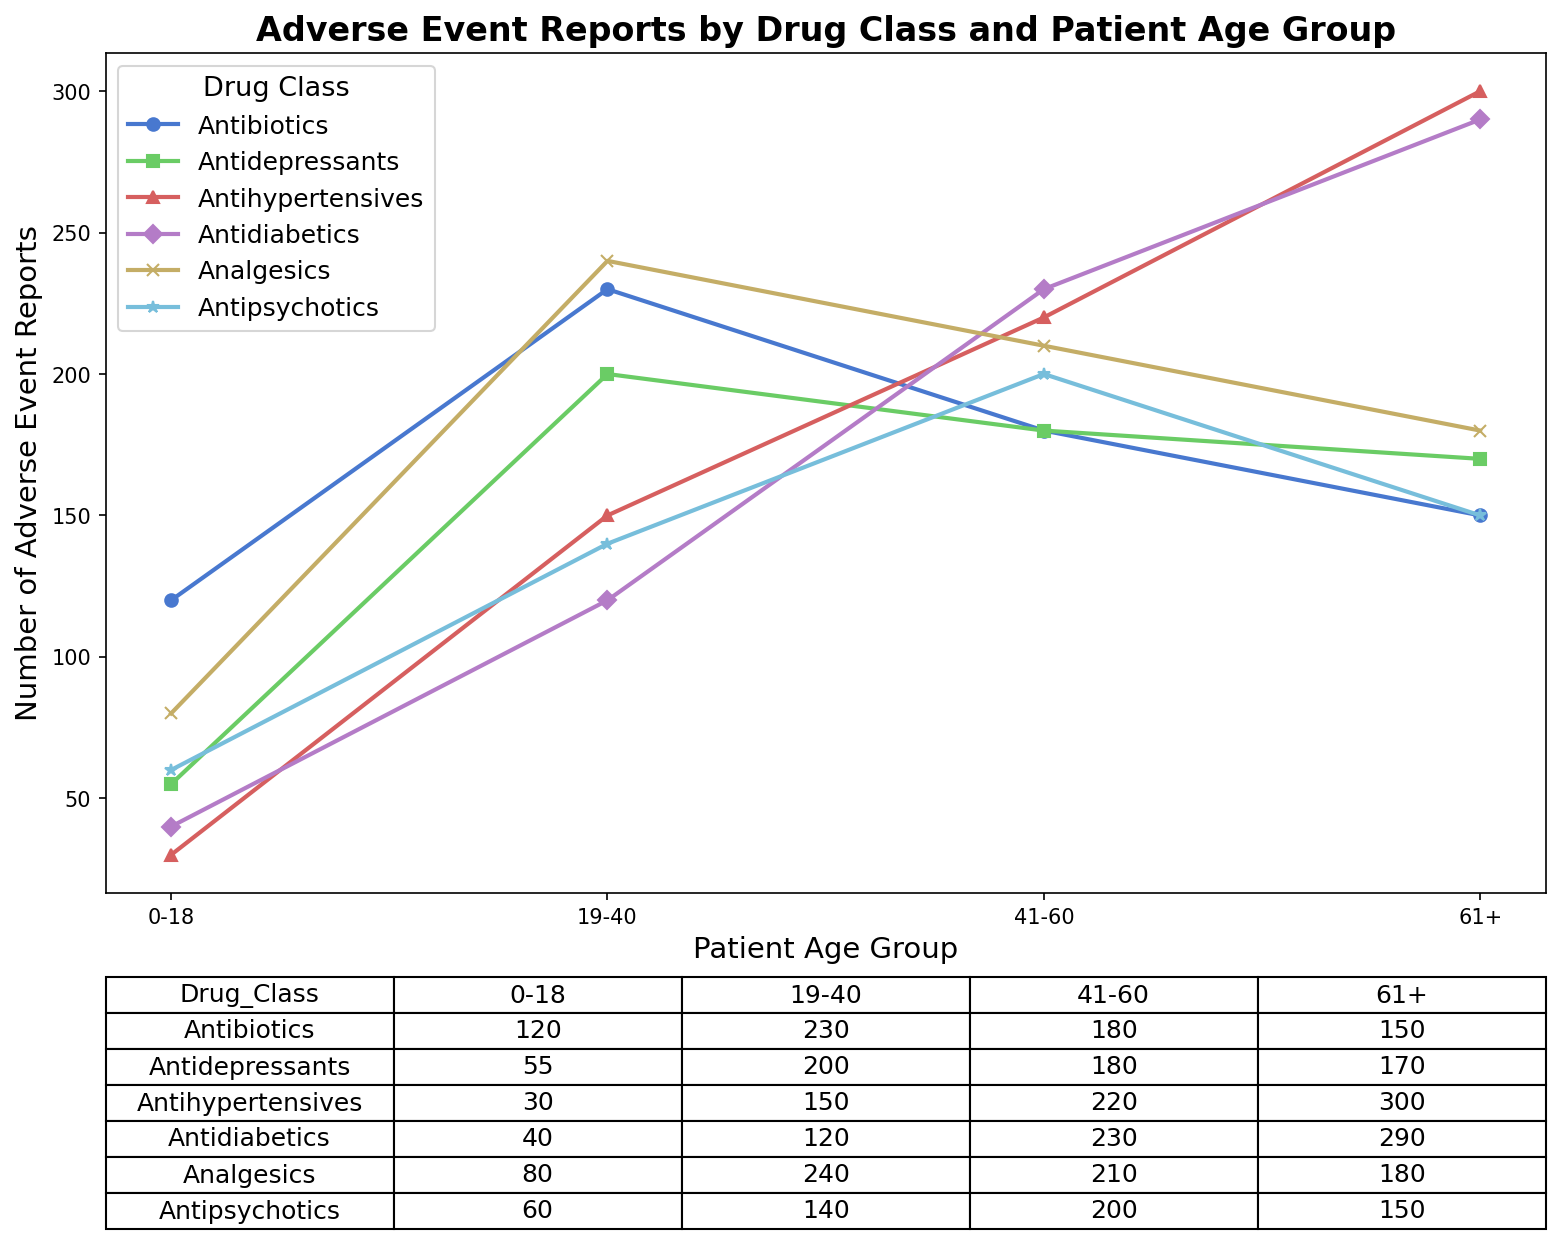Which drug class has the highest number of adverse event reports for the 61+ age group? Look at the 61+ age group column in the table and identify the drug class with the highest number, which is 300 for Antihypertensives.
Answer: Antihypertensives Which age group reports the most adverse events for Antibiotics? For Antibiotics, compare the numbers across the age groups: 0-18 (120), 19-40 (230), 41-60 (180), 61+ (150). The highest number is 230 for the 19-40 age group.
Answer: 19-40 How many more adverse event reports are there for Antihypertensives in the 61+ age group compared to the 0-18 age group? Subtract the number of reports for the 0-18 age group (30) from the number of reports for the 61+ age group (300). 300 - 30 = 270.
Answer: 270 Which drug class has the least number of adverse event reports for the 19-40 age group? Compare the numbers in the 19-40 age group column: Antibiotics (230), Antidepressants (200), Antihypertensives (150), Antidiabetics (120), Analgesics (240), Antipsychotics (140). The least number is 120 for Antidiabetics.
Answer: Antidiabetics What's the total number of adverse event reports for the 41-60 age group? Add the numbers in the 41-60 age group column: 180 (Antibiotics) + 180 (Antidepressants) + 220 (Antihypertensives) + 230 (Antidiabetics) + 210 (Analgesics) + 200 (Antipsychotics). The total is 1220.
Answer: 1220 By how much does the number of adverse event reports for Antipsychotics in the 41-60 age group exceed those for Antipsychotics in the 0-18 age group? Subtract the reports in the 0-18 age group (60) from those in the 41-60 age group (200). 200 - 60 = 140.
Answer: 140 Is the number of adverse event reports for Antidepressants in the 19-40 age group greater than that for Analgesics in the same age group? Compare the numbers: Antidepressants (200) and Analgesics (240). Since 200 is less than 240, the answer is no.
Answer: No Which age group has the lowest cumulative number of adverse event reports across all drug classes? Calculate the sum for each age group: 0-18: 120+55+30+40+80+60=385, 19-40: 230+200+150+120+240+140=1080, 41-60: 180+180+220+230+210+200=1220, 61+: 150+170+300+290+180+150=1240. The lowest total is for the 0-18 age group.
Answer: 0-18 Among the age groups, which reports fewer adverse events for Antidiabetics, 0-18 or 19-40? Compare the numbers for Antidiabetics: 0-18 (40) and 19-40 (120). The 0-18 group has fewer reports.
Answer: 0-18 